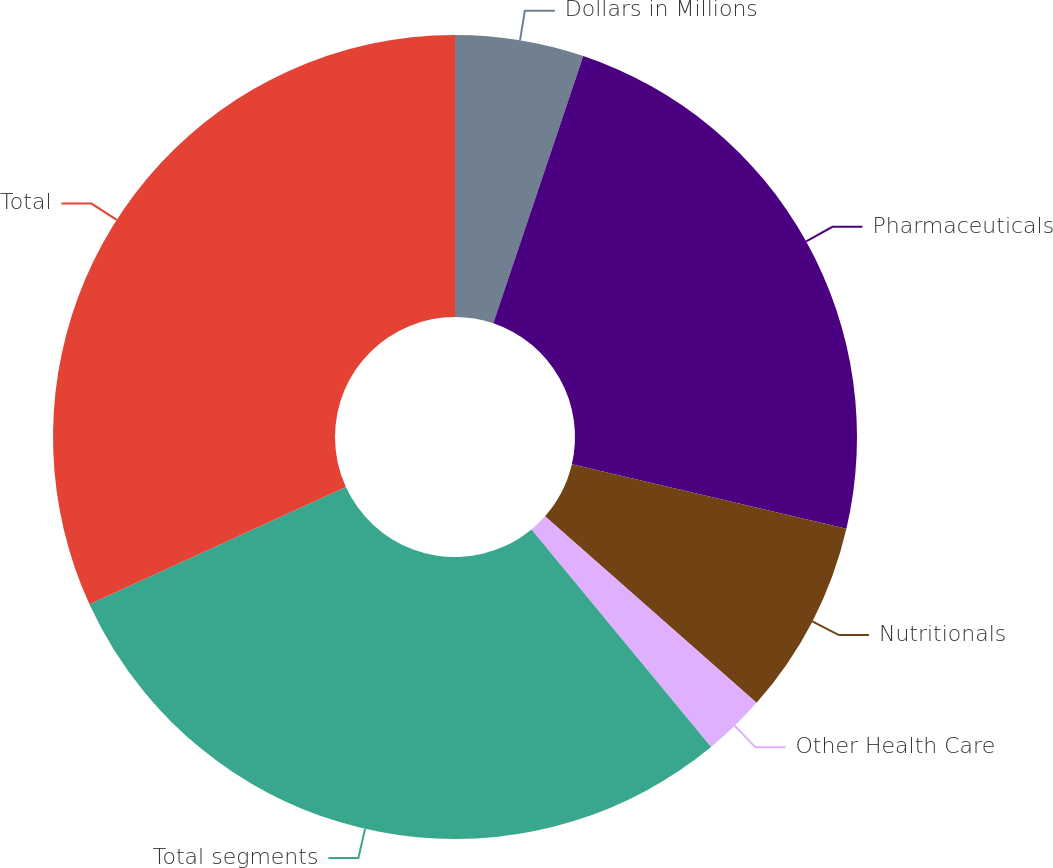Convert chart to OTSL. <chart><loc_0><loc_0><loc_500><loc_500><pie_chart><fcel>Dollars in Millions<fcel>Pharmaceuticals<fcel>Nutritionals<fcel>Other Health Care<fcel>Total segments<fcel>Total<nl><fcel>5.17%<fcel>23.49%<fcel>7.84%<fcel>2.51%<fcel>29.16%<fcel>31.83%<nl></chart> 